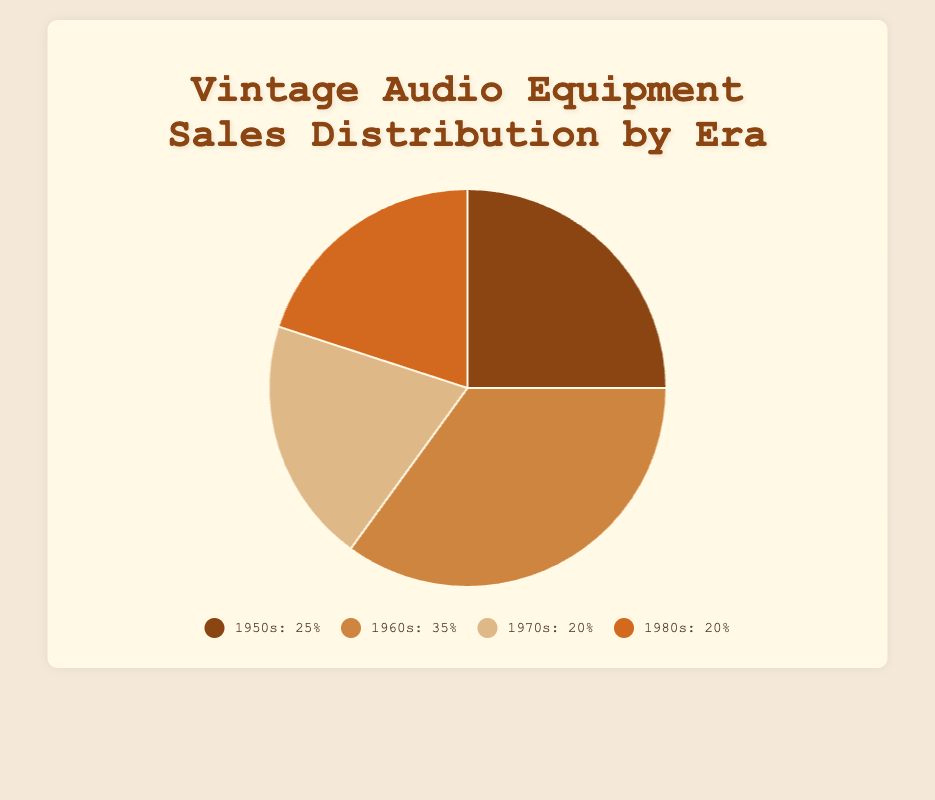Which era has the highest sales percentage and what is that percentage? By looking at the pie chart, the era with the largest portion will indicate the highest sales percentage. The era labeled "1960s" shows the largest section, thus having the highest sales percentage, which is 35%.
Answer: 1960s, 35% Which two eras have equal sales percentages? Comparing the sizes of the sections, the two era segments that appear equal are the 1970s and the 1980s, each with 20% of the sales distribution.
Answer: 1970s and 1980s What is the combined sales percentage of the 1950s and 1970s eras? Identifying the sections labeled "1950s" and "1970s", we add their respective sales percentages: 25% + 20% = 45%.
Answer: 45% Which era has the lowest average price, and what is it? Referring to the data, the era with the lowest average price among the popular items is the 1980s with an average price of $800.
Answer: 1980s, $800 How much larger, in percentage points, is the sales distribution of the 1960s compared to the 1970s? Subtract the percentage of the 1970s from the percentage of the 1960s: 35% - 20% = 15 percentage points.
Answer: 15 percentage points What is the average sales percentage across all eras? There are four eras. Summing the sales percentages and then dividing by 4: (25% + 35% + 20% + 20%) / 4 = 100% / 4 = 25%.
Answer: 25% If you combined the sales percentages of the 1970s and 1980s, would they be greater than the percentage of the 1960s? Adding the percentages of the 1970s and 1980s: 20% + 20% = 40%. Comparing this with 35% for the 1960s, 40% is indeed greater.
Answer: Yes, 40% > 35% Which era has a sales percentage that is closest to the average? The average sales percentage across all eras is 25%. The 1950s have a sales percentage of 25%, which is exactly the average.
Answer: 1950s What is the visual color representation of the 1960s era in the chart? Observing the pie chart, the 1960s section is in a light brown color.
Answer: Light brown How much higher is the average price of items from the 1950s compared to the 1980s? Subtracting the average price of the 1980s from the 1950s: $1500 - $800 = $700.
Answer: $700 What is the total sales percentage for the eras before the 1970s? Adding the sales percentages for the 1950s and 1960s: 25% + 35% = 60%.
Answer: 60% 